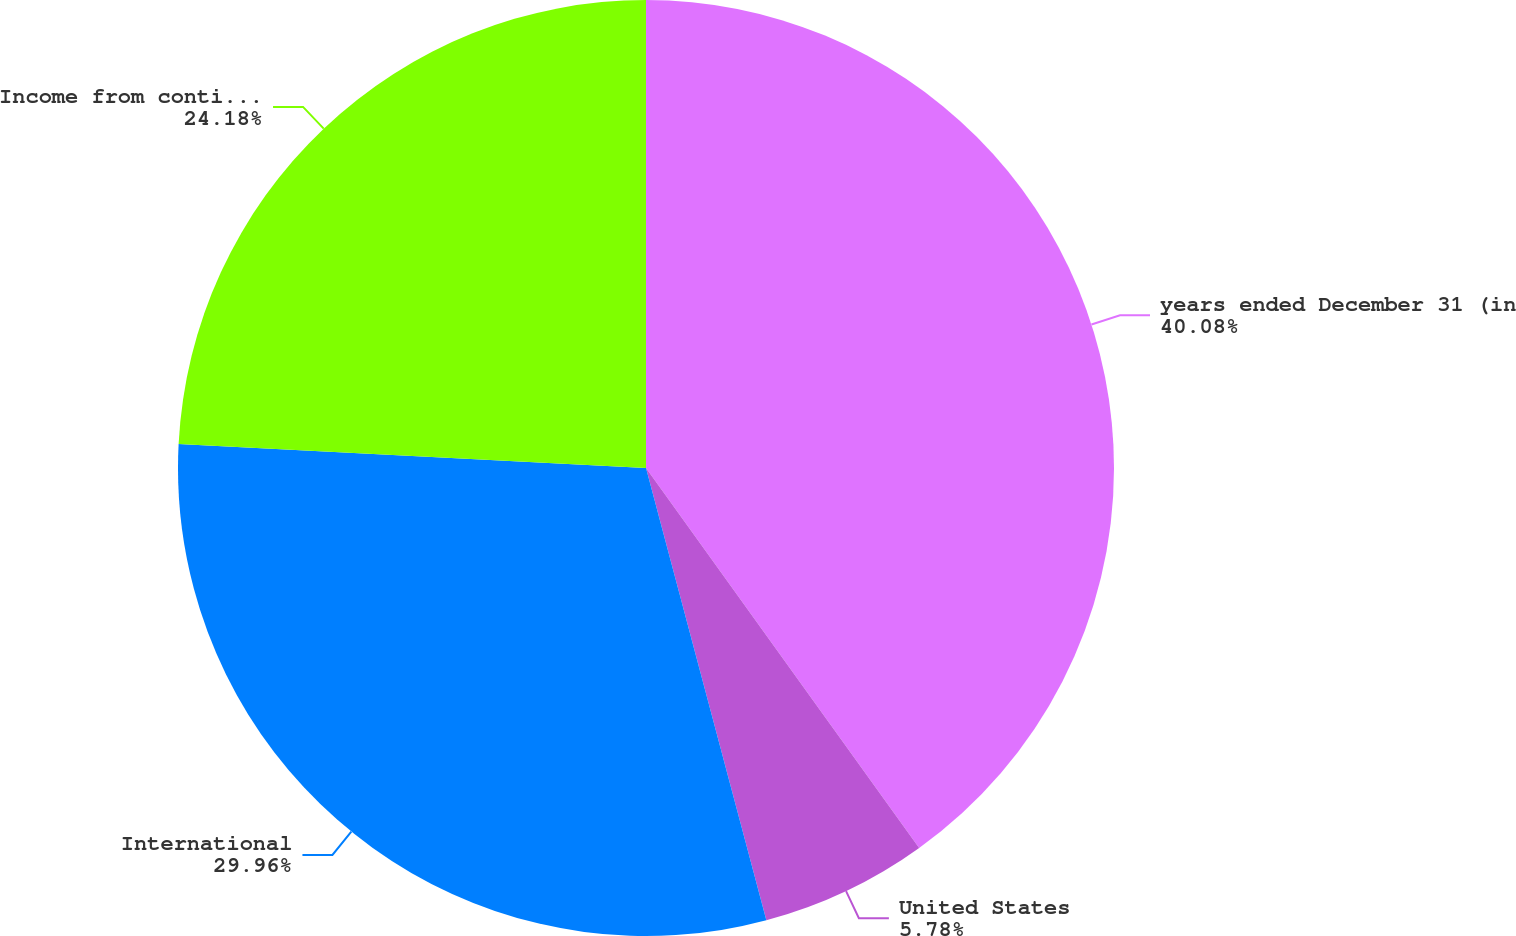<chart> <loc_0><loc_0><loc_500><loc_500><pie_chart><fcel>years ended December 31 (in<fcel>United States<fcel>International<fcel>Income from continuing<nl><fcel>40.08%<fcel>5.78%<fcel>29.96%<fcel>24.18%<nl></chart> 